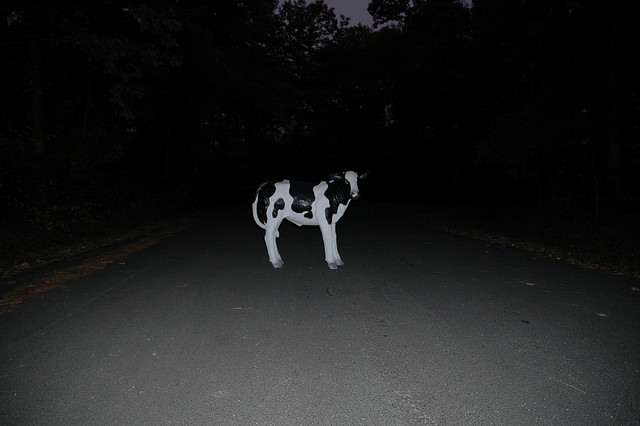<image>What type of room is this? It is not identifiable what type of room this is as it's outside or outdoors. What type of room is this? I am not sure what type of room this is. It can be outdoors or outside. 